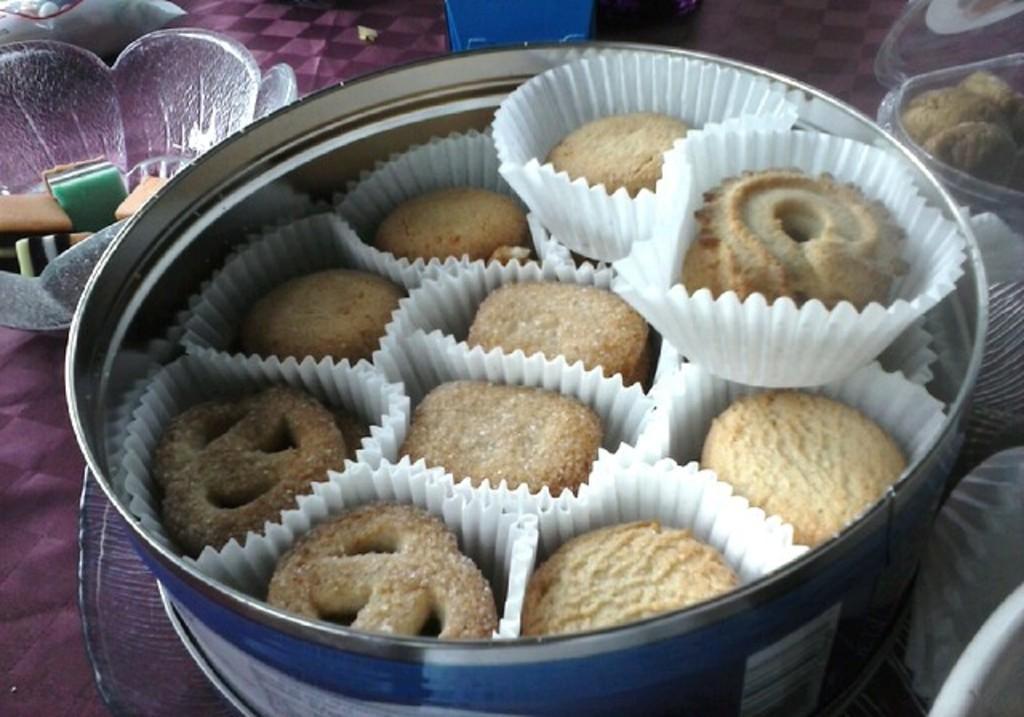Describe this image in one or two sentences. In this image there are so many food items arranged in the bowls, which are on the table and there are few other objects. 